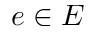<formula> <loc_0><loc_0><loc_500><loc_500>e \in E</formula> 